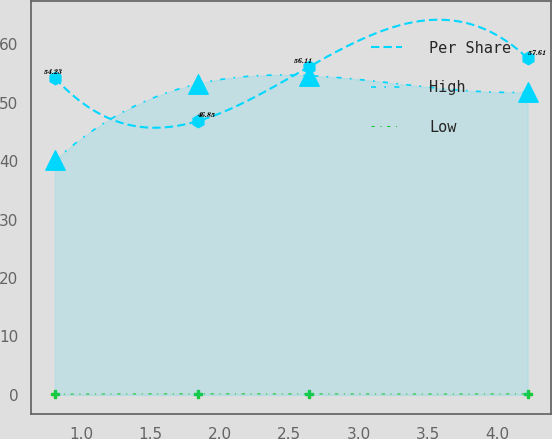<chart> <loc_0><loc_0><loc_500><loc_500><line_chart><ecel><fcel>Per Share<fcel>High<fcel>Low<nl><fcel>0.81<fcel>54.23<fcel>40.13<fcel>0.12<nl><fcel>1.84<fcel>46.85<fcel>53.22<fcel>0.19<nl><fcel>2.64<fcel>56.11<fcel>54.64<fcel>0.17<nl><fcel>4.22<fcel>57.61<fcel>51.8<fcel>0.18<nl></chart> 